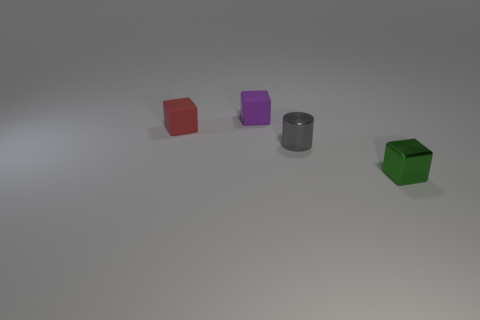How many tiny gray things have the same shape as the purple thing?
Your answer should be very brief. 0. What color is the shiny thing that is the same size as the gray shiny cylinder?
Provide a succinct answer. Green. Is the number of small gray metallic things that are behind the tiny red cube the same as the number of tiny purple cubes that are behind the green shiny thing?
Your response must be concise. No. Is there a gray shiny thing that has the same size as the green shiny object?
Offer a very short reply. Yes. Is the number of tiny red rubber blocks behind the small cylinder the same as the number of tiny purple objects?
Your response must be concise. Yes. How many other objects are there of the same color as the tiny shiny cube?
Keep it short and to the point. 0. What is the color of the tiny object that is both on the left side of the green cube and in front of the small red rubber block?
Ensure brevity in your answer.  Gray. What number of things are either tiny things to the left of the gray shiny thing or small rubber blocks in front of the tiny purple matte block?
Provide a short and direct response. 2. The gray object has what shape?
Keep it short and to the point. Cylinder. What is the size of the green shiny object that is the same shape as the small purple thing?
Offer a terse response. Small. 